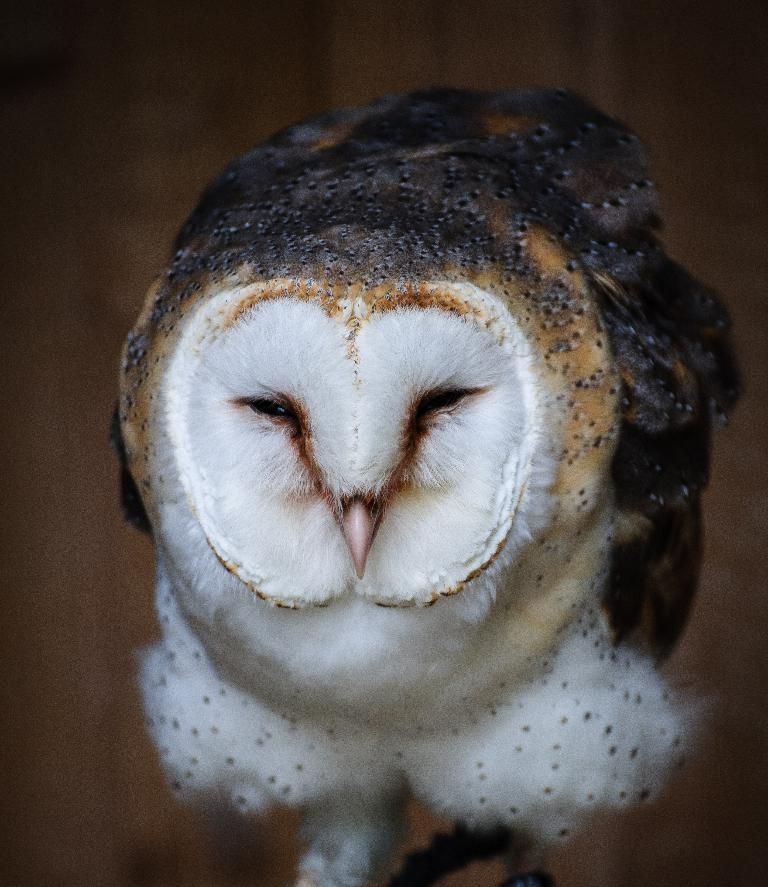What type of animal is in the image? There is a bird in the image. What colors can be seen on the bird? The bird is in white and black color. Can you describe the background of the image? The background of the image is blurry. How many pets are visible in the image? There are no pets visible in the image; it features a bird. What is the fifth element in the image? The facts provided do not mention five elements in the image, so it is not possible to answer this question. 